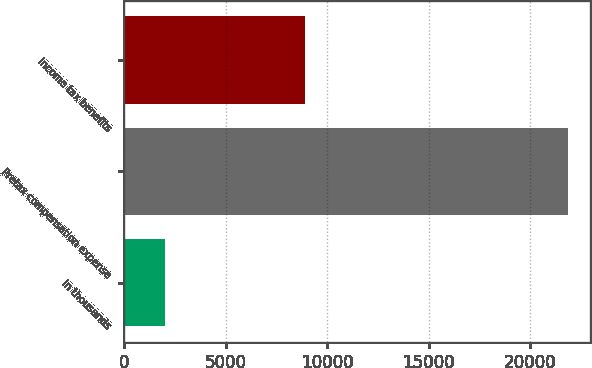Convert chart. <chart><loc_0><loc_0><loc_500><loc_500><bar_chart><fcel>in thousands<fcel>Pretax compensation expense<fcel>Income tax benefits<nl><fcel>2009<fcel>21861<fcel>8915<nl></chart> 